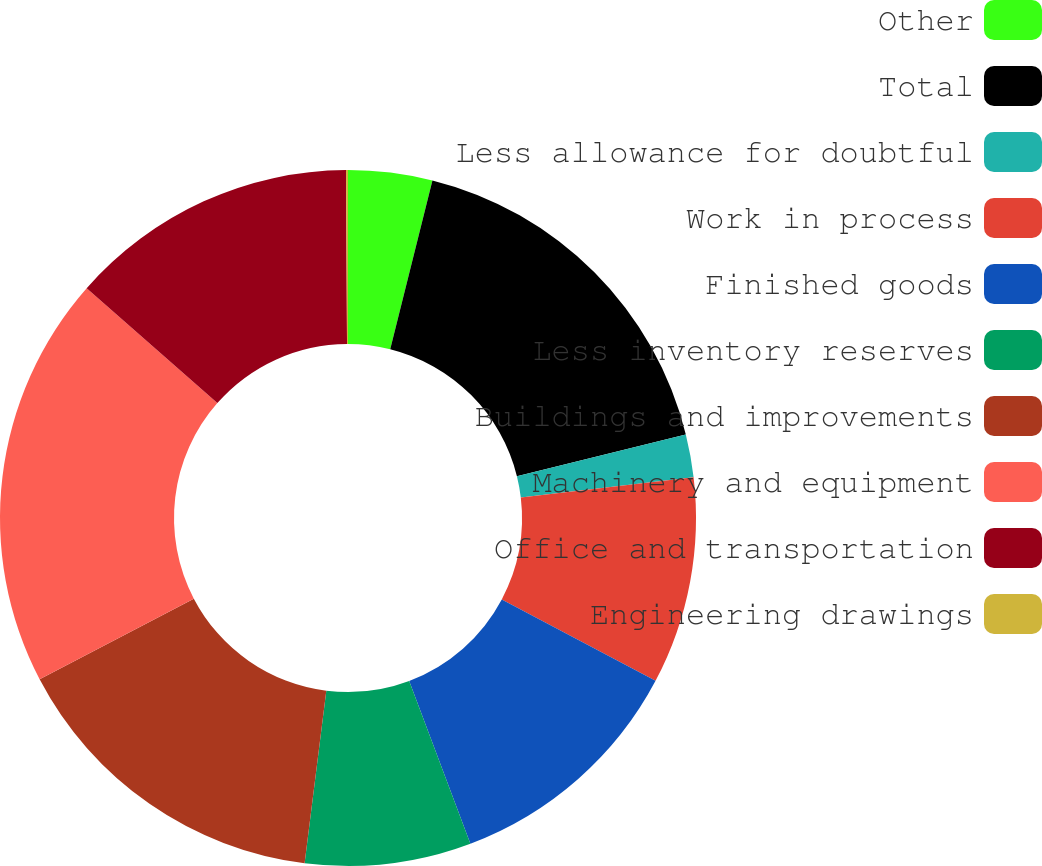Convert chart to OTSL. <chart><loc_0><loc_0><loc_500><loc_500><pie_chart><fcel>Other<fcel>Total<fcel>Less allowance for doubtful<fcel>Work in process<fcel>Finished goods<fcel>Less inventory reserves<fcel>Buildings and improvements<fcel>Machinery and equipment<fcel>Office and transportation<fcel>Engineering drawings<nl><fcel>3.9%<fcel>17.24%<fcel>1.99%<fcel>9.62%<fcel>11.53%<fcel>7.71%<fcel>15.34%<fcel>19.15%<fcel>13.43%<fcel>0.09%<nl></chart> 